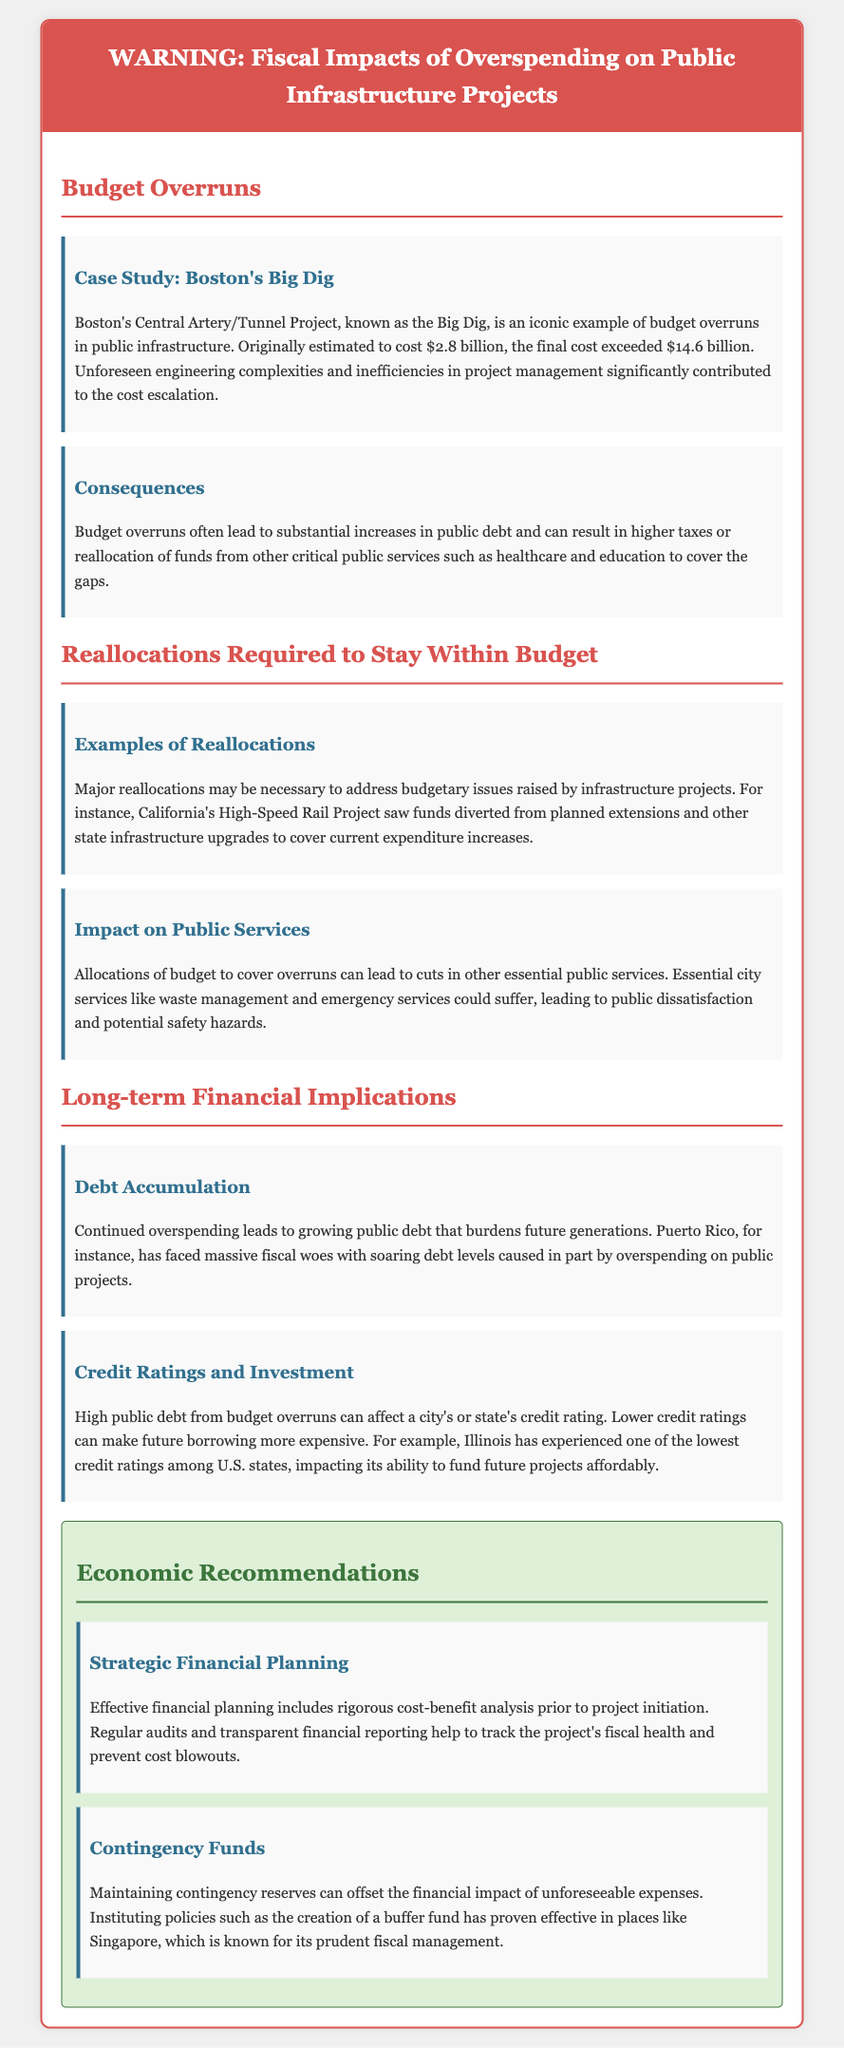What is the estimated cost of the Big Dig project? The original estimated cost of the Big Dig project was $2.8 billion.
Answer: $2.8 billion What was the final cost of the Big Dig project? The final cost of the Big Dig project exceeded $14.6 billion.
Answer: $14.6 billion What is a consequence of budget overruns mentioned in the document? One consequence of budget overruns is substantial increases in public debt.
Answer: Public debt What significant project example is given for reallocations? The California High-Speed Rail Project is mentioned as an example of reallocations.
Answer: California High-Speed Rail Project What has led to massive fiscal woes in Puerto Rico? Overspending on public projects has contributed to massive fiscal woes in Puerto Rico.
Answer: Overspending What is one of the recommendations for managing financial impacts? One recommendation is maintaining contingency reserves.
Answer: Contingency reserves Which state's credit ratings have been affected by public debt from budget overruns? Illinois has experienced low credit ratings due to public debt.
Answer: Illinois What is the suggested practice for effective financial planning? Rigorous cost-benefit analysis is suggested for effective financial planning.
Answer: Cost-benefit analysis What critical public services might be affected by budget reallocations? Essential city services like waste management might be affected.
Answer: Waste management 